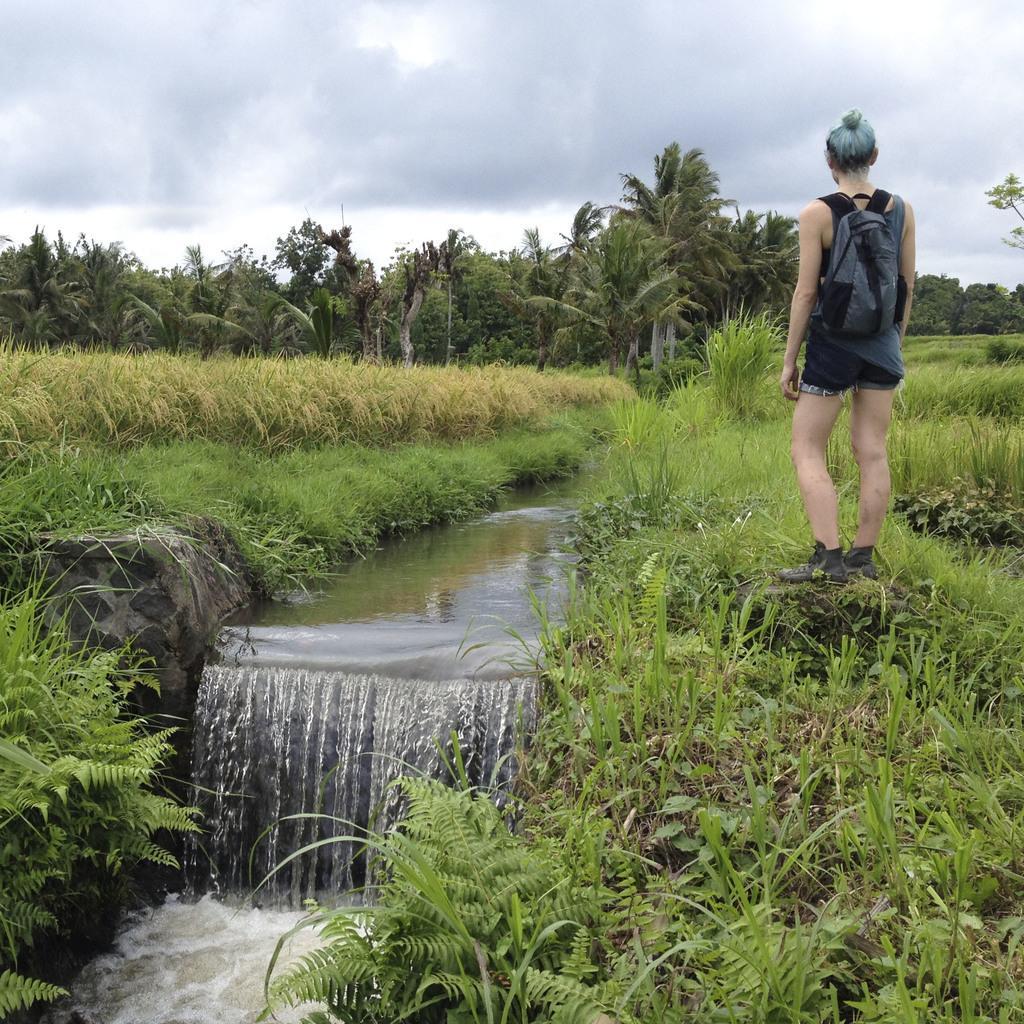Can you describe this image briefly? In the image I can see a water flow in between the grass fields and also I can see a person who is wearing the backpack and some trees to the side. 